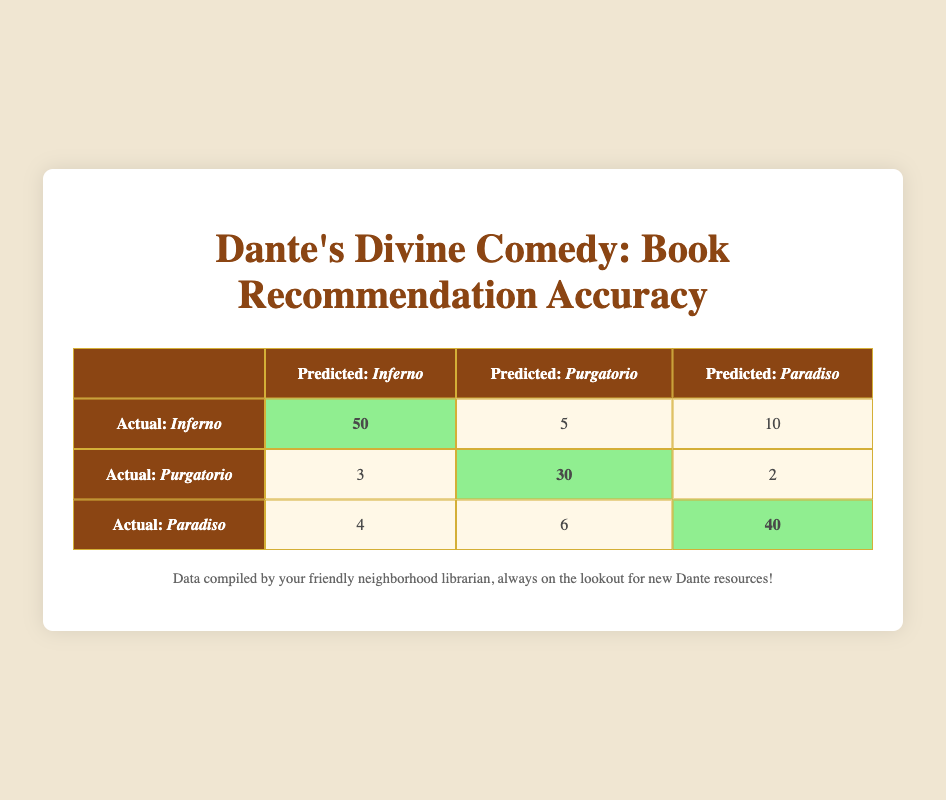What is the total number of correct predictions for Purgatorio? The table indicates that there are 30 correct predictions for Purgatorio. Therefore, the total number of correct predictions is 30.
Answer: 30 How many incorrect predictions were made for Inferno? The table shows that there are 5 incorrect predictions for Purgatorio and 10 for Paradiso when the actual book was Inferno. Adding these gives 5 + 10 = 15 incorrect predictions.
Answer: 15 What is the total number of predictions made for Paradiso? The total predictions for Paradiso can be found by adding the correct predictions (40) to the incorrect predictions (6 from Inferno and 4 from Purgatorio). Therefore, the total is 40 + 6 + 4 = 50.
Answer: 50 Did the number of correct predictions for Inferno exceed the total number of incorrect predictions for Purgatorio? The correct predictions for Inferno are 50, while the incorrect predictions for Purgatorio are 3 from Inferno and 2 from Paradiso, totaling 5. Since 50 is greater than 5, the statement is true.
Answer: Yes What percentage of total predictions were correct for Paradise? The correct predictions for Paradiso are 40. The total predictions can be calculated as 40 (correct predictions) + 4 (incorrect predictions from Inferno) + 6 (incorrect predictions from Purgatorio) = 50. To find the percentage, we use (40/50) * 100 = 80%.
Answer: 80% How many more incorrect predictions were made for Purgatorio than for Paradiso? For Purgatorio, there are 3 incorrect predictions when the actual book was Inferno and 2 when it was Paradiso, totaling 5. For Paradiso, there are 4 from Inferno and 6 from Purgatorio, totaling 10. Therefore, Purgatorio had 5 - 10 = -5 more incorrect predictions than Paradiso, meaning Paradiso had 5 more incorrect predictions.
Answer: Paradiso had 5 more incorrect predictions 